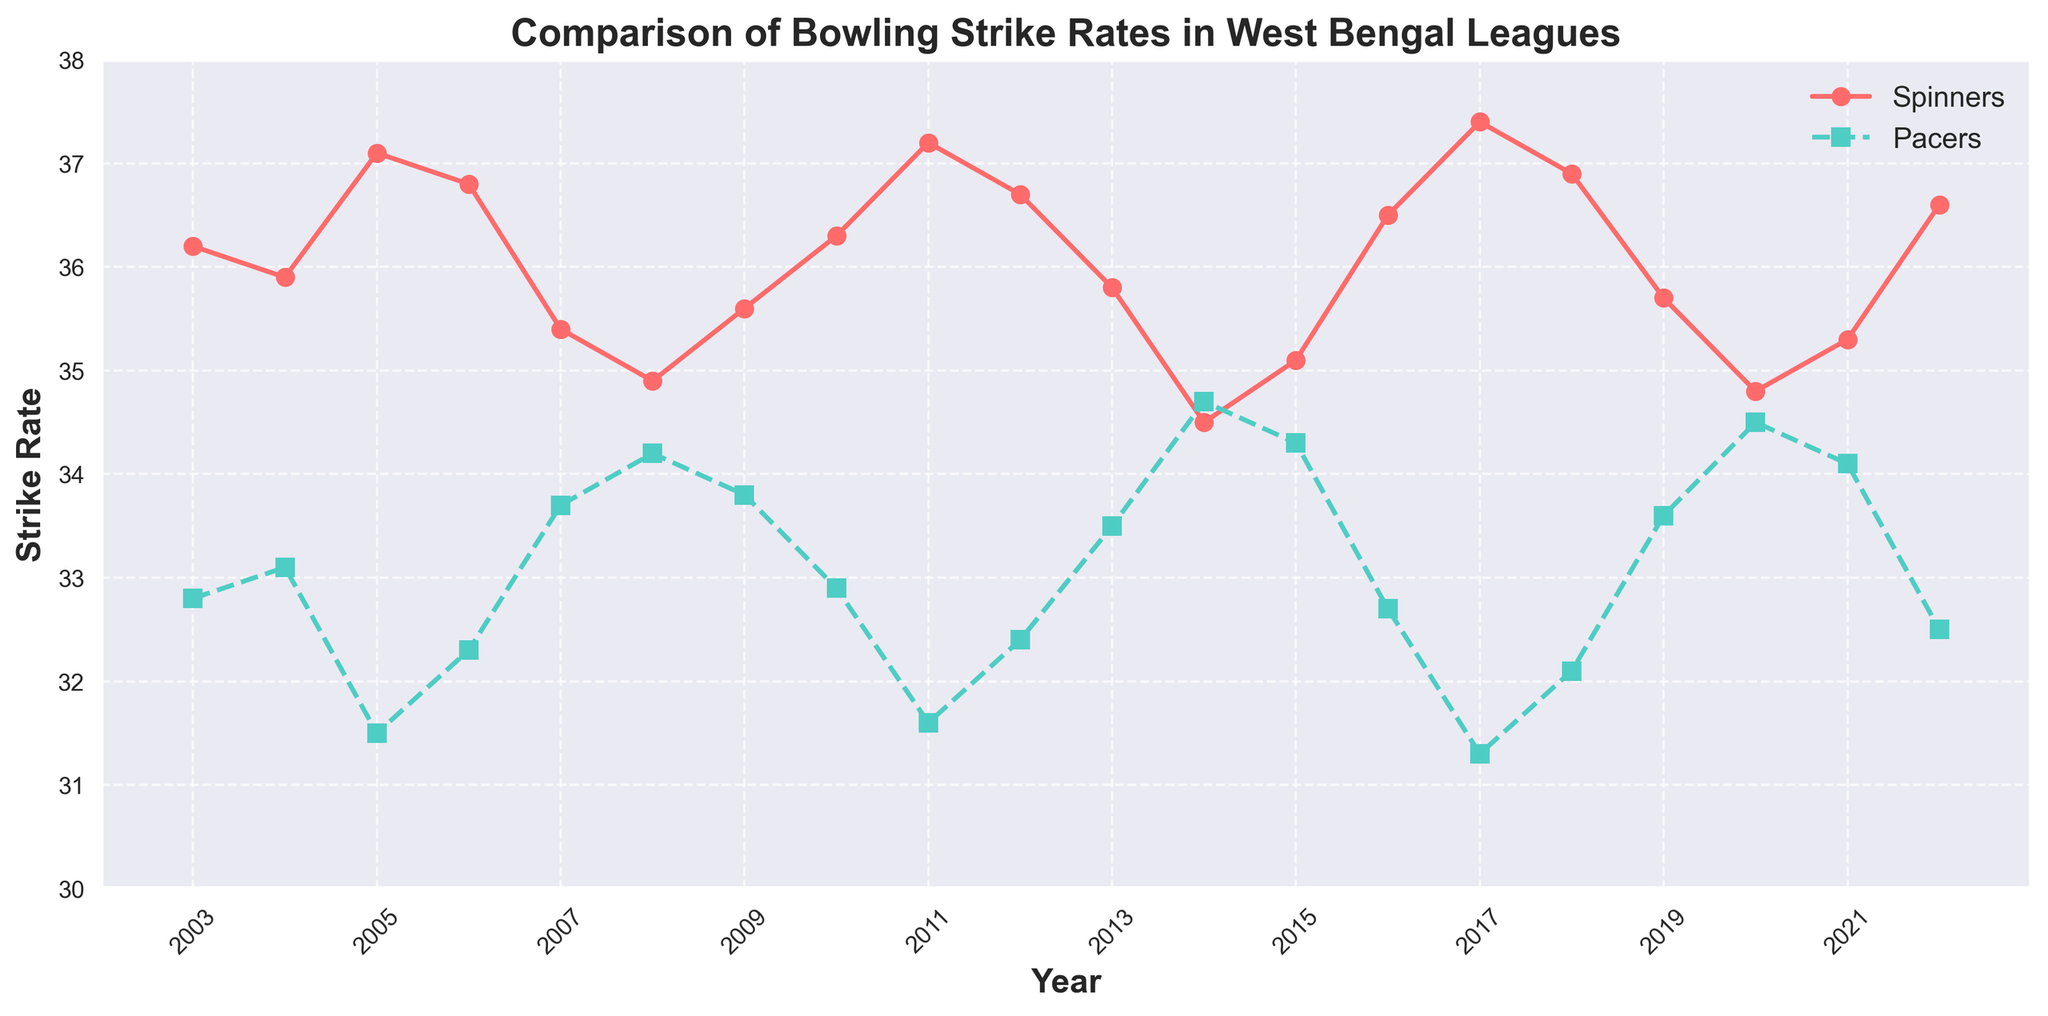Which type of bowler had a better strike rate overall between 2003 and 2022? To determine which type of bowler had a better strike rate overall, observe the plotted lines. The pacers' strike rate (dashed green line) is consistently lower than the spinners' (solid red line) for most years. Lower strike rates are better in bowling, indicating pacers had better strike rates.
Answer: Pacers In which year did the spinners have the highest strike rate? Look for the highest point on the solid red line representing the spinners. The peak is in 2017, where the strike rate is around 37.4.
Answer: 2017 How does the strike rate trend of pacers compare to spinners between 2015 and 2020? Compare the trends of the two lines between 2015 and 2020. Both lines show fluctuations, but while spinners' strike rate generally decreases from 36.5 in 2016 to around 34.8 in 2020, pacers’ strike rate increases from 32.7 to 34.5 over the same period.
Answer: Spinners decrease, pacers increase What is the difference in strike rates between spinners and pacers in 2022? Find the values for 2022 on both lines. The spinners' strike rate is 36.6, and the pacers' strike rate is 32.5. The difference is 36.6 - 32.5.
Answer: 4.1 In which year did both spinners and pacers have the closest strike rates? Compare the proximity of the two lines’ values for different years. 2014 has the closest strike rates where spinners have around 34.5, and pacers have around 34.7, a difference of about 0.2.
Answer: 2014 What was the average strike rate of spinners from 2009 to 2013? Sum the strike rates for spinners from 2009 (35.6), 2010 (36.3), 2011 (37.2), 2012 (36.7), and 2013 (35.8), and divide by 5. (35.6 + 36.3 + 37.2 + 36.7 + 35.8)/5 = 36.32
Answer: 36.32 Between pacers and spinners, who showed a more consistent strike rate from 2003 to 2022? Consistency can be inferred from the fluctuation range in the lines. The pacers’ strike rates (dashed green line) fluctuate less compared to the spinners (solid red line), showing more consistency.
Answer: Pacers Was there any year when the strike rate of pacers was higher than that of spinners? Look for any year where the green dashed line is higher than the solid red line. This occurred in 2004, 2007, 2008, and 2020.
Answer: Yes, several years (2004, 2007, 2008, 2020) What is the overall trend in strike rates for both spinners and pacers over the two decades? Both lines show a general fluctuation with no clear long-term trend indicating an overall increase or decrease.
Answer: Fluctuates with no clear trend 